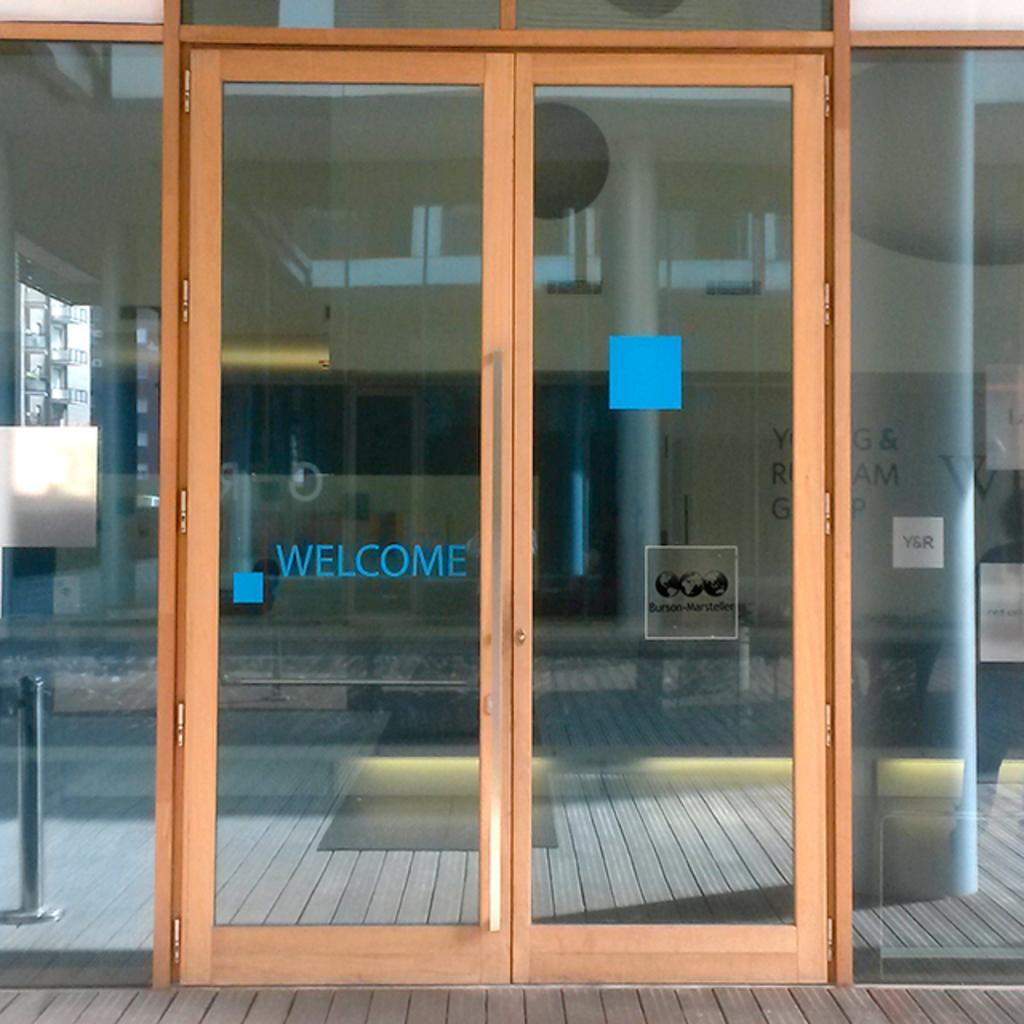In one or two sentences, can you explain what this image depicts? In the given image i can see a door and behind the door i can see a building with some text on it. 